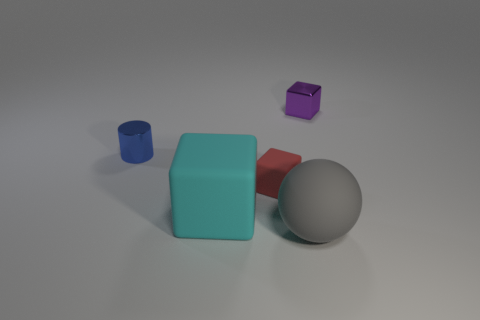Add 5 blue objects. How many objects exist? 10 Subtract all cylinders. How many objects are left? 4 Subtract all big balls. Subtract all small rubber things. How many objects are left? 3 Add 1 tiny metallic objects. How many tiny metallic objects are left? 3 Add 5 large gray rubber things. How many large gray rubber things exist? 6 Subtract 0 yellow cubes. How many objects are left? 5 